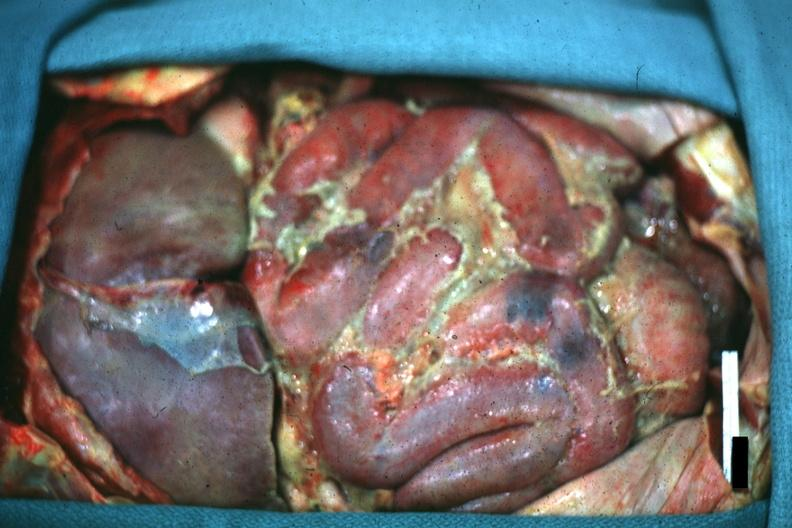s abdomen present?
Answer the question using a single word or phrase. Yes 